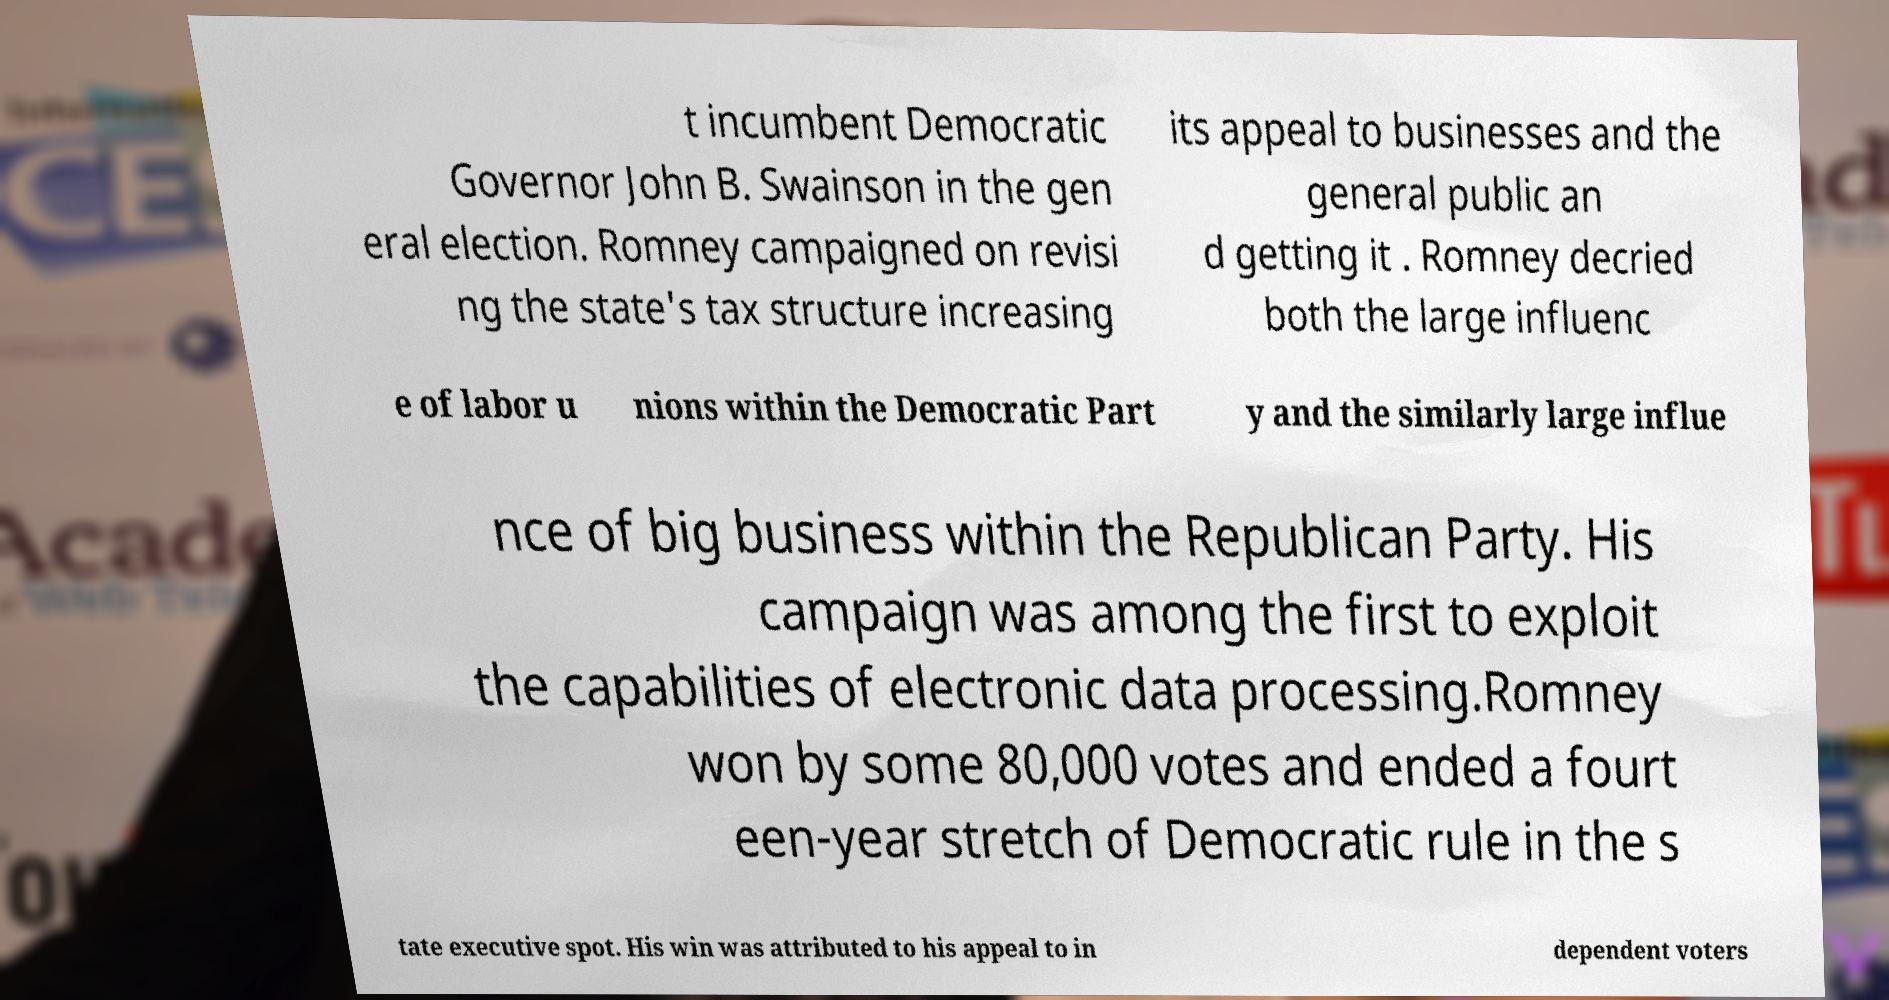What messages or text are displayed in this image? I need them in a readable, typed format. t incumbent Democratic Governor John B. Swainson in the gen eral election. Romney campaigned on revisi ng the state's tax structure increasing its appeal to businesses and the general public an d getting it . Romney decried both the large influenc e of labor u nions within the Democratic Part y and the similarly large influe nce of big business within the Republican Party. His campaign was among the first to exploit the capabilities of electronic data processing.Romney won by some 80,000 votes and ended a fourt een-year stretch of Democratic rule in the s tate executive spot. His win was attributed to his appeal to in dependent voters 